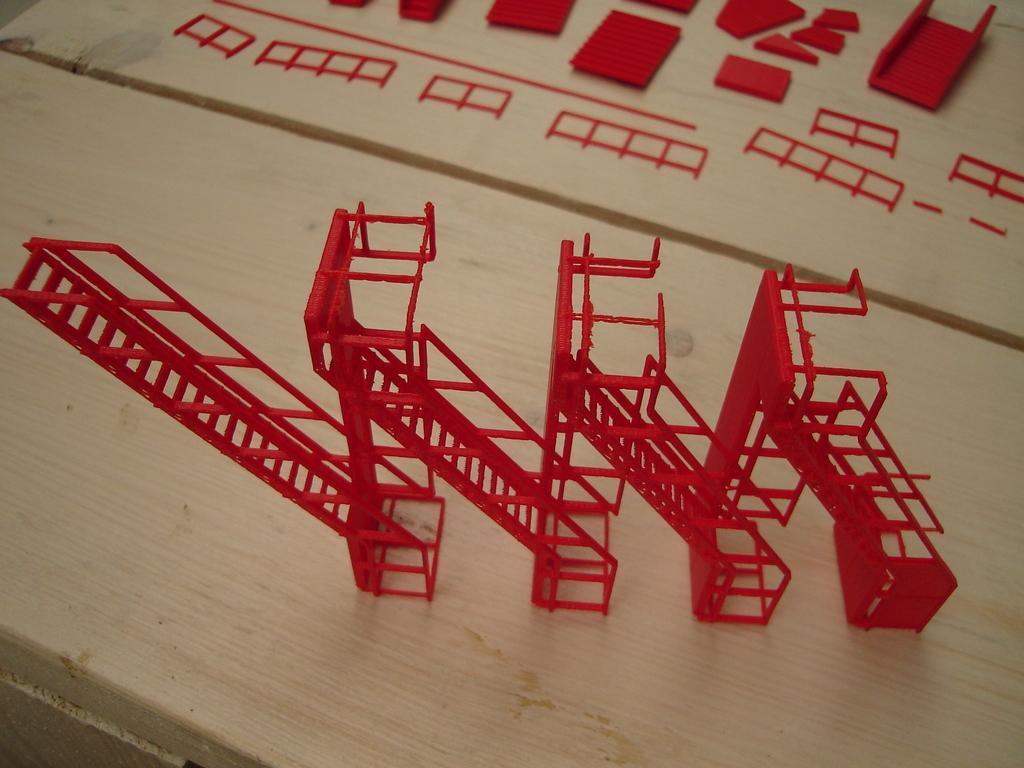Can you describe this image briefly? On a wooden surface we can see a staircase model in red color. These are parts of the staircase model. 